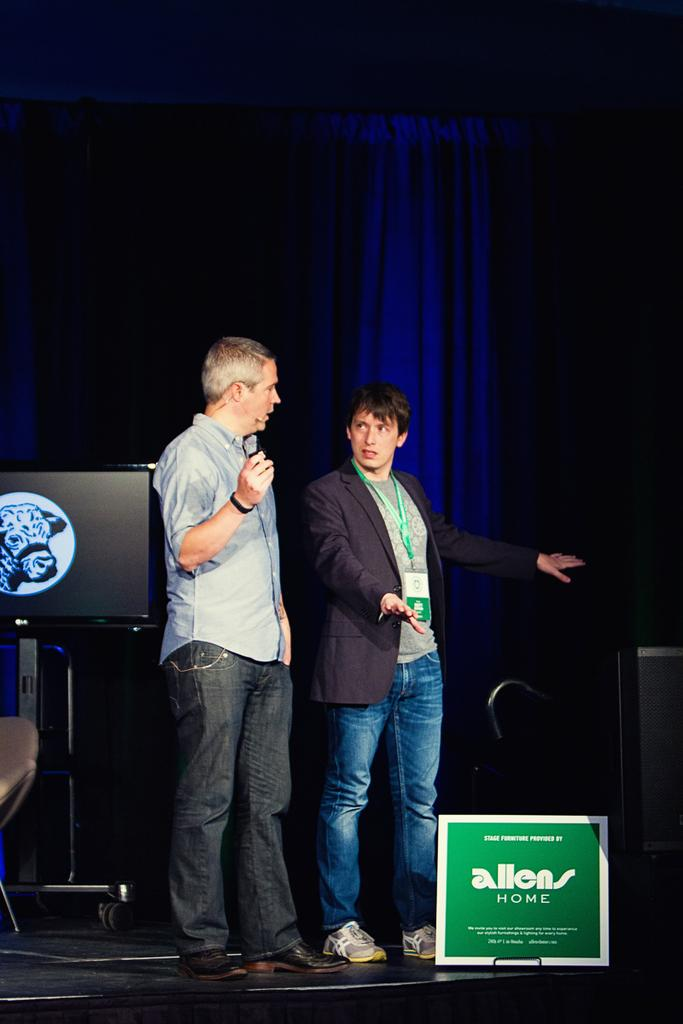How many people are on the stage in the image? There are two men standing on the stage in the image. What can be seen on the stand in the image? There is a television on a stand in the image. What is written on the board in the image? There is a board with some text on it in the image. What is present in the image that might be used to separate or reveal a performance area? There is a curtain in the image. How many pizzas are being served on the stage in the image? There are no pizzas present in the image; it features two men standing on the stage, a television on a stand, a board with text, and a curtain. 